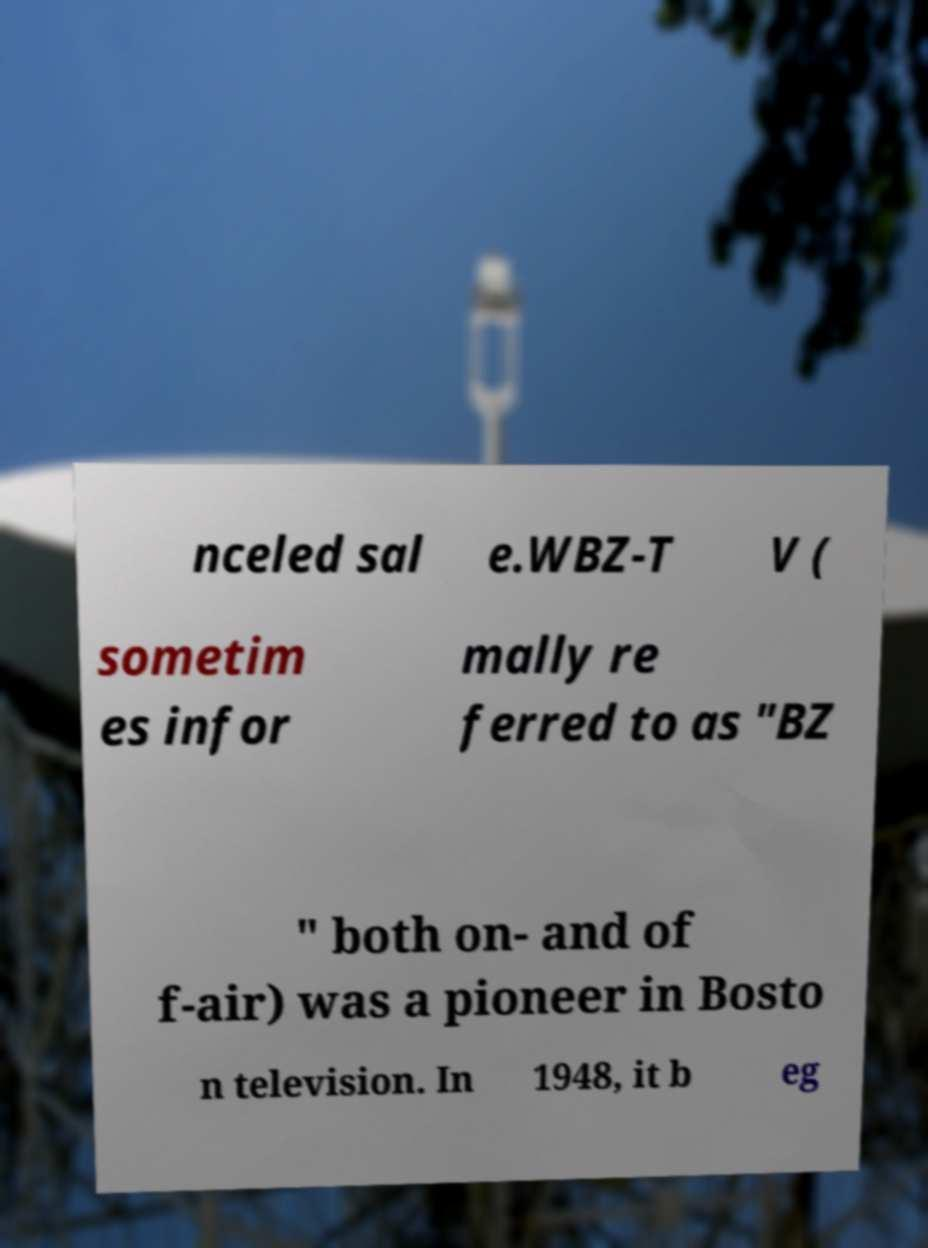Please read and relay the text visible in this image. What does it say? nceled sal e.WBZ-T V ( sometim es infor mally re ferred to as "BZ " both on- and of f-air) was a pioneer in Bosto n television. In 1948, it b eg 